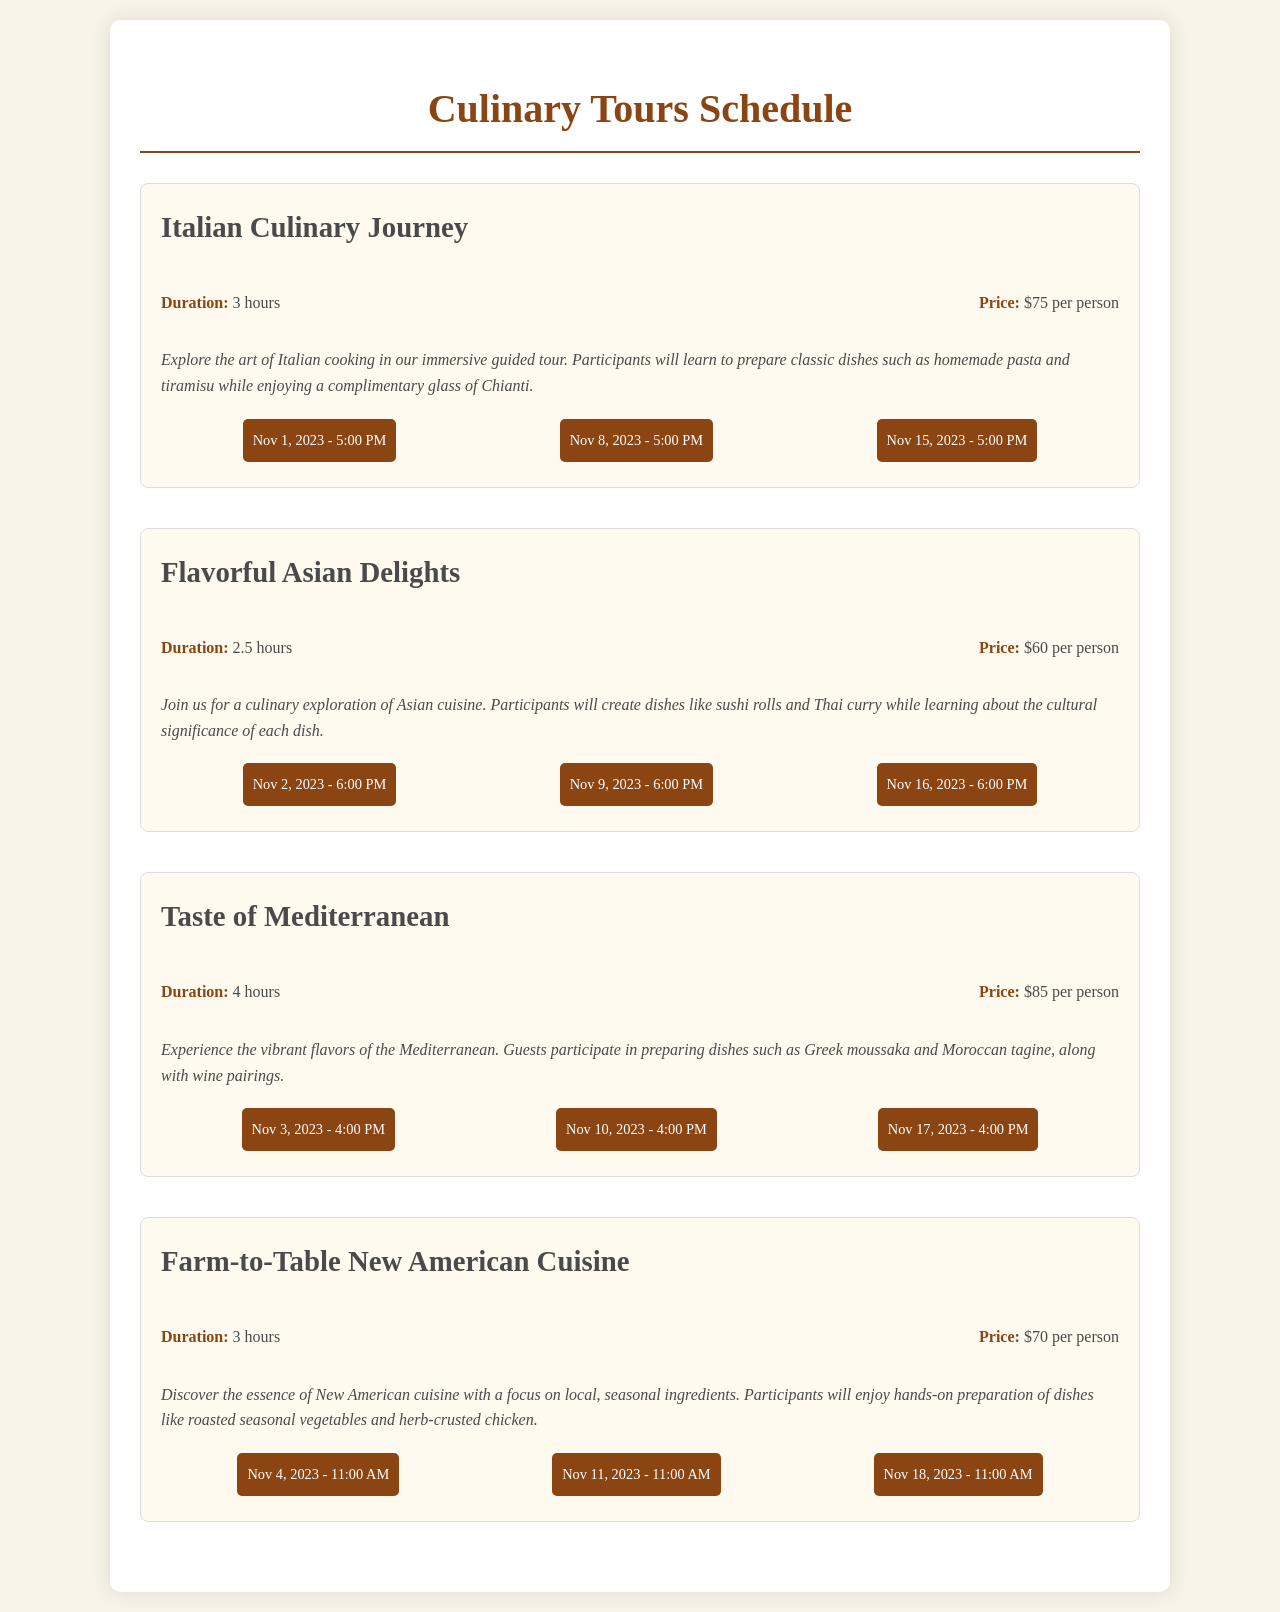What is the price for the Italian Culinary Journey? The price for the Italian Culinary Journey is listed in the document under the tour info section.
Answer: $75 per person What is the duration of the Flavorful Asian Delights tour? The duration is specified in the tour info section for this particular culinary tour.
Answer: 2.5 hours On what date is the Taste of Mediterranean tour scheduled for November? This can be found in the schedule section for the Taste of Mediterranean, showing the dates in November.
Answer: Nov 3, 2023 - 4:00 PM How many total culinary tours are listed in the document? The total number of tours can be counted from the number of separate tour listings in the document.
Answer: 4 Which culinary tour lasts the longest? Comparing the durations provided in each tour's information section helps determine this.
Answer: Taste of Mediterranean What is the starting time for the Farm-to-Table New American Cuisine tour? The starting times are listed under the schedule for this specific tour.
Answer: 11:00 AM Which tour includes making sushi rolls? The information about what participants will create is found in the description of each tour.
Answer: Flavorful Asian Delights What type of cuisine is focused on local, seasonal ingredients? This can be inferred from the description of the respective culinary tour.
Answer: New American Cuisine 